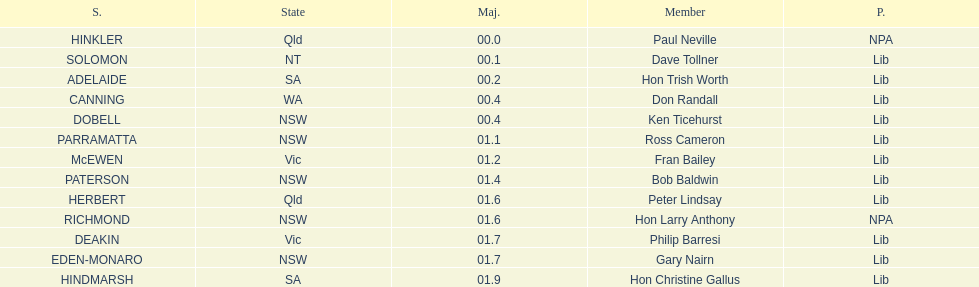How many members in total? 13. 